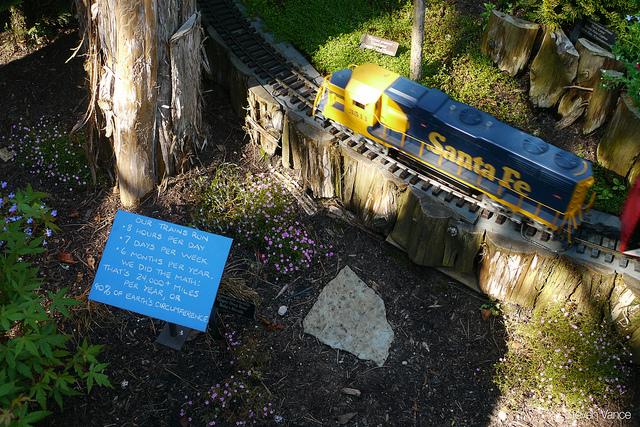Who planted this?
Write a very short answer. Gardener. What does the train's first read?
Keep it brief. Santa fe. Is this a real train?
Be succinct. No. 